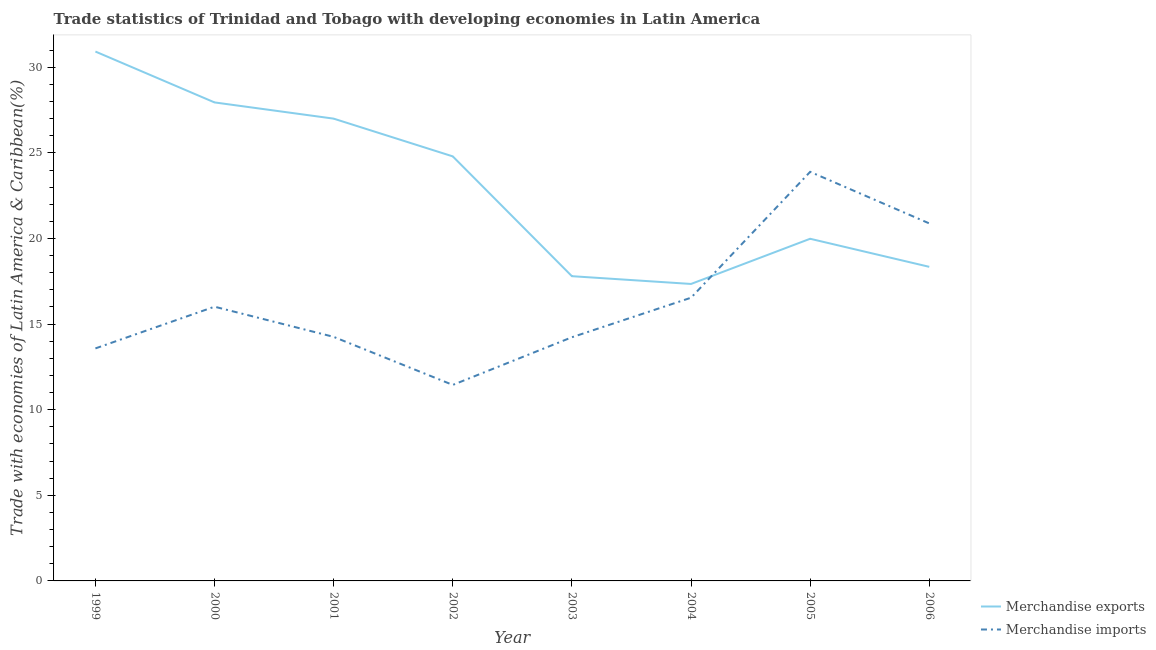Does the line corresponding to merchandise imports intersect with the line corresponding to merchandise exports?
Your answer should be compact. Yes. Is the number of lines equal to the number of legend labels?
Make the answer very short. Yes. What is the merchandise imports in 2005?
Make the answer very short. 23.89. Across all years, what is the maximum merchandise imports?
Offer a terse response. 23.89. Across all years, what is the minimum merchandise imports?
Provide a short and direct response. 11.45. What is the total merchandise exports in the graph?
Your answer should be very brief. 184.13. What is the difference between the merchandise imports in 1999 and that in 2005?
Your answer should be very brief. -10.31. What is the difference between the merchandise imports in 2003 and the merchandise exports in 2005?
Make the answer very short. -5.75. What is the average merchandise imports per year?
Keep it short and to the point. 16.36. In the year 2004, what is the difference between the merchandise imports and merchandise exports?
Your answer should be very brief. -0.8. In how many years, is the merchandise imports greater than 9 %?
Your answer should be very brief. 8. What is the ratio of the merchandise imports in 2001 to that in 2005?
Ensure brevity in your answer.  0.6. What is the difference between the highest and the second highest merchandise exports?
Give a very brief answer. 2.97. What is the difference between the highest and the lowest merchandise exports?
Provide a short and direct response. 13.57. Does the merchandise exports monotonically increase over the years?
Your answer should be compact. No. Is the merchandise exports strictly greater than the merchandise imports over the years?
Keep it short and to the point. No. Is the merchandise exports strictly less than the merchandise imports over the years?
Offer a very short reply. No. How many years are there in the graph?
Provide a succinct answer. 8. Does the graph contain grids?
Make the answer very short. No. What is the title of the graph?
Keep it short and to the point. Trade statistics of Trinidad and Tobago with developing economies in Latin America. What is the label or title of the Y-axis?
Provide a short and direct response. Trade with economies of Latin America & Caribbean(%). What is the Trade with economies of Latin America & Caribbean(%) in Merchandise exports in 1999?
Offer a terse response. 30.92. What is the Trade with economies of Latin America & Caribbean(%) of Merchandise imports in 1999?
Your answer should be compact. 13.58. What is the Trade with economies of Latin America & Caribbean(%) in Merchandise exports in 2000?
Ensure brevity in your answer.  27.95. What is the Trade with economies of Latin America & Caribbean(%) in Merchandise imports in 2000?
Ensure brevity in your answer.  16.02. What is the Trade with economies of Latin America & Caribbean(%) of Merchandise exports in 2001?
Keep it short and to the point. 27. What is the Trade with economies of Latin America & Caribbean(%) of Merchandise imports in 2001?
Your response must be concise. 14.25. What is the Trade with economies of Latin America & Caribbean(%) in Merchandise exports in 2002?
Make the answer very short. 24.8. What is the Trade with economies of Latin America & Caribbean(%) of Merchandise imports in 2002?
Your response must be concise. 11.45. What is the Trade with economies of Latin America & Caribbean(%) in Merchandise exports in 2003?
Keep it short and to the point. 17.8. What is the Trade with economies of Latin America & Caribbean(%) in Merchandise imports in 2003?
Make the answer very short. 14.23. What is the Trade with economies of Latin America & Caribbean(%) in Merchandise exports in 2004?
Your answer should be very brief. 17.34. What is the Trade with economies of Latin America & Caribbean(%) in Merchandise imports in 2004?
Offer a terse response. 16.54. What is the Trade with economies of Latin America & Caribbean(%) of Merchandise exports in 2005?
Provide a short and direct response. 19.98. What is the Trade with economies of Latin America & Caribbean(%) of Merchandise imports in 2005?
Make the answer very short. 23.89. What is the Trade with economies of Latin America & Caribbean(%) in Merchandise exports in 2006?
Provide a succinct answer. 18.34. What is the Trade with economies of Latin America & Caribbean(%) of Merchandise imports in 2006?
Your answer should be compact. 20.88. Across all years, what is the maximum Trade with economies of Latin America & Caribbean(%) in Merchandise exports?
Keep it short and to the point. 30.92. Across all years, what is the maximum Trade with economies of Latin America & Caribbean(%) of Merchandise imports?
Your answer should be compact. 23.89. Across all years, what is the minimum Trade with economies of Latin America & Caribbean(%) in Merchandise exports?
Offer a very short reply. 17.34. Across all years, what is the minimum Trade with economies of Latin America & Caribbean(%) of Merchandise imports?
Offer a terse response. 11.45. What is the total Trade with economies of Latin America & Caribbean(%) in Merchandise exports in the graph?
Your response must be concise. 184.13. What is the total Trade with economies of Latin America & Caribbean(%) of Merchandise imports in the graph?
Provide a succinct answer. 130.85. What is the difference between the Trade with economies of Latin America & Caribbean(%) in Merchandise exports in 1999 and that in 2000?
Provide a short and direct response. 2.97. What is the difference between the Trade with economies of Latin America & Caribbean(%) of Merchandise imports in 1999 and that in 2000?
Your answer should be compact. -2.44. What is the difference between the Trade with economies of Latin America & Caribbean(%) in Merchandise exports in 1999 and that in 2001?
Give a very brief answer. 3.92. What is the difference between the Trade with economies of Latin America & Caribbean(%) in Merchandise imports in 1999 and that in 2001?
Ensure brevity in your answer.  -0.67. What is the difference between the Trade with economies of Latin America & Caribbean(%) in Merchandise exports in 1999 and that in 2002?
Your response must be concise. 6.12. What is the difference between the Trade with economies of Latin America & Caribbean(%) in Merchandise imports in 1999 and that in 2002?
Provide a succinct answer. 2.13. What is the difference between the Trade with economies of Latin America & Caribbean(%) of Merchandise exports in 1999 and that in 2003?
Provide a short and direct response. 13.12. What is the difference between the Trade with economies of Latin America & Caribbean(%) of Merchandise imports in 1999 and that in 2003?
Ensure brevity in your answer.  -0.65. What is the difference between the Trade with economies of Latin America & Caribbean(%) in Merchandise exports in 1999 and that in 2004?
Make the answer very short. 13.57. What is the difference between the Trade with economies of Latin America & Caribbean(%) in Merchandise imports in 1999 and that in 2004?
Make the answer very short. -2.96. What is the difference between the Trade with economies of Latin America & Caribbean(%) of Merchandise exports in 1999 and that in 2005?
Ensure brevity in your answer.  10.94. What is the difference between the Trade with economies of Latin America & Caribbean(%) in Merchandise imports in 1999 and that in 2005?
Your answer should be very brief. -10.31. What is the difference between the Trade with economies of Latin America & Caribbean(%) in Merchandise exports in 1999 and that in 2006?
Provide a succinct answer. 12.57. What is the difference between the Trade with economies of Latin America & Caribbean(%) in Merchandise imports in 1999 and that in 2006?
Your answer should be compact. -7.3. What is the difference between the Trade with economies of Latin America & Caribbean(%) in Merchandise exports in 2000 and that in 2001?
Your answer should be compact. 0.95. What is the difference between the Trade with economies of Latin America & Caribbean(%) of Merchandise imports in 2000 and that in 2001?
Ensure brevity in your answer.  1.76. What is the difference between the Trade with economies of Latin America & Caribbean(%) of Merchandise exports in 2000 and that in 2002?
Offer a very short reply. 3.15. What is the difference between the Trade with economies of Latin America & Caribbean(%) in Merchandise imports in 2000 and that in 2002?
Your response must be concise. 4.57. What is the difference between the Trade with economies of Latin America & Caribbean(%) in Merchandise exports in 2000 and that in 2003?
Ensure brevity in your answer.  10.15. What is the difference between the Trade with economies of Latin America & Caribbean(%) in Merchandise imports in 2000 and that in 2003?
Offer a terse response. 1.78. What is the difference between the Trade with economies of Latin America & Caribbean(%) in Merchandise exports in 2000 and that in 2004?
Your answer should be compact. 10.6. What is the difference between the Trade with economies of Latin America & Caribbean(%) in Merchandise imports in 2000 and that in 2004?
Your answer should be very brief. -0.52. What is the difference between the Trade with economies of Latin America & Caribbean(%) in Merchandise exports in 2000 and that in 2005?
Offer a terse response. 7.96. What is the difference between the Trade with economies of Latin America & Caribbean(%) in Merchandise imports in 2000 and that in 2005?
Your answer should be compact. -7.88. What is the difference between the Trade with economies of Latin America & Caribbean(%) of Merchandise exports in 2000 and that in 2006?
Make the answer very short. 9.6. What is the difference between the Trade with economies of Latin America & Caribbean(%) of Merchandise imports in 2000 and that in 2006?
Offer a terse response. -4.86. What is the difference between the Trade with economies of Latin America & Caribbean(%) of Merchandise exports in 2001 and that in 2002?
Offer a very short reply. 2.2. What is the difference between the Trade with economies of Latin America & Caribbean(%) in Merchandise imports in 2001 and that in 2002?
Offer a very short reply. 2.81. What is the difference between the Trade with economies of Latin America & Caribbean(%) in Merchandise exports in 2001 and that in 2003?
Offer a very short reply. 9.2. What is the difference between the Trade with economies of Latin America & Caribbean(%) of Merchandise imports in 2001 and that in 2003?
Your answer should be compact. 0.02. What is the difference between the Trade with economies of Latin America & Caribbean(%) of Merchandise exports in 2001 and that in 2004?
Keep it short and to the point. 9.66. What is the difference between the Trade with economies of Latin America & Caribbean(%) in Merchandise imports in 2001 and that in 2004?
Your answer should be very brief. -2.29. What is the difference between the Trade with economies of Latin America & Caribbean(%) in Merchandise exports in 2001 and that in 2005?
Provide a succinct answer. 7.02. What is the difference between the Trade with economies of Latin America & Caribbean(%) in Merchandise imports in 2001 and that in 2005?
Your answer should be very brief. -9.64. What is the difference between the Trade with economies of Latin America & Caribbean(%) of Merchandise exports in 2001 and that in 2006?
Offer a very short reply. 8.66. What is the difference between the Trade with economies of Latin America & Caribbean(%) of Merchandise imports in 2001 and that in 2006?
Offer a very short reply. -6.63. What is the difference between the Trade with economies of Latin America & Caribbean(%) of Merchandise exports in 2002 and that in 2003?
Make the answer very short. 7. What is the difference between the Trade with economies of Latin America & Caribbean(%) in Merchandise imports in 2002 and that in 2003?
Provide a succinct answer. -2.78. What is the difference between the Trade with economies of Latin America & Caribbean(%) of Merchandise exports in 2002 and that in 2004?
Your response must be concise. 7.45. What is the difference between the Trade with economies of Latin America & Caribbean(%) in Merchandise imports in 2002 and that in 2004?
Give a very brief answer. -5.09. What is the difference between the Trade with economies of Latin America & Caribbean(%) in Merchandise exports in 2002 and that in 2005?
Your response must be concise. 4.81. What is the difference between the Trade with economies of Latin America & Caribbean(%) of Merchandise imports in 2002 and that in 2005?
Your answer should be very brief. -12.45. What is the difference between the Trade with economies of Latin America & Caribbean(%) of Merchandise exports in 2002 and that in 2006?
Keep it short and to the point. 6.45. What is the difference between the Trade with economies of Latin America & Caribbean(%) in Merchandise imports in 2002 and that in 2006?
Offer a terse response. -9.43. What is the difference between the Trade with economies of Latin America & Caribbean(%) of Merchandise exports in 2003 and that in 2004?
Provide a succinct answer. 0.45. What is the difference between the Trade with economies of Latin America & Caribbean(%) in Merchandise imports in 2003 and that in 2004?
Offer a very short reply. -2.31. What is the difference between the Trade with economies of Latin America & Caribbean(%) of Merchandise exports in 2003 and that in 2005?
Your answer should be compact. -2.19. What is the difference between the Trade with economies of Latin America & Caribbean(%) in Merchandise imports in 2003 and that in 2005?
Offer a terse response. -9.66. What is the difference between the Trade with economies of Latin America & Caribbean(%) of Merchandise exports in 2003 and that in 2006?
Give a very brief answer. -0.55. What is the difference between the Trade with economies of Latin America & Caribbean(%) of Merchandise imports in 2003 and that in 2006?
Provide a succinct answer. -6.65. What is the difference between the Trade with economies of Latin America & Caribbean(%) in Merchandise exports in 2004 and that in 2005?
Provide a short and direct response. -2.64. What is the difference between the Trade with economies of Latin America & Caribbean(%) of Merchandise imports in 2004 and that in 2005?
Provide a short and direct response. -7.35. What is the difference between the Trade with economies of Latin America & Caribbean(%) of Merchandise exports in 2004 and that in 2006?
Provide a short and direct response. -1. What is the difference between the Trade with economies of Latin America & Caribbean(%) of Merchandise imports in 2004 and that in 2006?
Your answer should be very brief. -4.34. What is the difference between the Trade with economies of Latin America & Caribbean(%) in Merchandise exports in 2005 and that in 2006?
Offer a terse response. 1.64. What is the difference between the Trade with economies of Latin America & Caribbean(%) in Merchandise imports in 2005 and that in 2006?
Provide a short and direct response. 3.01. What is the difference between the Trade with economies of Latin America & Caribbean(%) in Merchandise exports in 1999 and the Trade with economies of Latin America & Caribbean(%) in Merchandise imports in 2000?
Your answer should be very brief. 14.9. What is the difference between the Trade with economies of Latin America & Caribbean(%) in Merchandise exports in 1999 and the Trade with economies of Latin America & Caribbean(%) in Merchandise imports in 2001?
Keep it short and to the point. 16.66. What is the difference between the Trade with economies of Latin America & Caribbean(%) of Merchandise exports in 1999 and the Trade with economies of Latin America & Caribbean(%) of Merchandise imports in 2002?
Your answer should be compact. 19.47. What is the difference between the Trade with economies of Latin America & Caribbean(%) in Merchandise exports in 1999 and the Trade with economies of Latin America & Caribbean(%) in Merchandise imports in 2003?
Your answer should be compact. 16.69. What is the difference between the Trade with economies of Latin America & Caribbean(%) in Merchandise exports in 1999 and the Trade with economies of Latin America & Caribbean(%) in Merchandise imports in 2004?
Make the answer very short. 14.38. What is the difference between the Trade with economies of Latin America & Caribbean(%) of Merchandise exports in 1999 and the Trade with economies of Latin America & Caribbean(%) of Merchandise imports in 2005?
Offer a very short reply. 7.03. What is the difference between the Trade with economies of Latin America & Caribbean(%) in Merchandise exports in 1999 and the Trade with economies of Latin America & Caribbean(%) in Merchandise imports in 2006?
Your response must be concise. 10.04. What is the difference between the Trade with economies of Latin America & Caribbean(%) of Merchandise exports in 2000 and the Trade with economies of Latin America & Caribbean(%) of Merchandise imports in 2001?
Your answer should be compact. 13.69. What is the difference between the Trade with economies of Latin America & Caribbean(%) in Merchandise exports in 2000 and the Trade with economies of Latin America & Caribbean(%) in Merchandise imports in 2002?
Offer a very short reply. 16.5. What is the difference between the Trade with economies of Latin America & Caribbean(%) of Merchandise exports in 2000 and the Trade with economies of Latin America & Caribbean(%) of Merchandise imports in 2003?
Provide a short and direct response. 13.72. What is the difference between the Trade with economies of Latin America & Caribbean(%) of Merchandise exports in 2000 and the Trade with economies of Latin America & Caribbean(%) of Merchandise imports in 2004?
Provide a short and direct response. 11.41. What is the difference between the Trade with economies of Latin America & Caribbean(%) in Merchandise exports in 2000 and the Trade with economies of Latin America & Caribbean(%) in Merchandise imports in 2005?
Offer a very short reply. 4.05. What is the difference between the Trade with economies of Latin America & Caribbean(%) in Merchandise exports in 2000 and the Trade with economies of Latin America & Caribbean(%) in Merchandise imports in 2006?
Provide a succinct answer. 7.07. What is the difference between the Trade with economies of Latin America & Caribbean(%) of Merchandise exports in 2001 and the Trade with economies of Latin America & Caribbean(%) of Merchandise imports in 2002?
Give a very brief answer. 15.55. What is the difference between the Trade with economies of Latin America & Caribbean(%) of Merchandise exports in 2001 and the Trade with economies of Latin America & Caribbean(%) of Merchandise imports in 2003?
Your answer should be compact. 12.77. What is the difference between the Trade with economies of Latin America & Caribbean(%) of Merchandise exports in 2001 and the Trade with economies of Latin America & Caribbean(%) of Merchandise imports in 2004?
Provide a succinct answer. 10.46. What is the difference between the Trade with economies of Latin America & Caribbean(%) in Merchandise exports in 2001 and the Trade with economies of Latin America & Caribbean(%) in Merchandise imports in 2005?
Offer a terse response. 3.11. What is the difference between the Trade with economies of Latin America & Caribbean(%) in Merchandise exports in 2001 and the Trade with economies of Latin America & Caribbean(%) in Merchandise imports in 2006?
Provide a short and direct response. 6.12. What is the difference between the Trade with economies of Latin America & Caribbean(%) in Merchandise exports in 2002 and the Trade with economies of Latin America & Caribbean(%) in Merchandise imports in 2003?
Your response must be concise. 10.56. What is the difference between the Trade with economies of Latin America & Caribbean(%) in Merchandise exports in 2002 and the Trade with economies of Latin America & Caribbean(%) in Merchandise imports in 2004?
Your answer should be compact. 8.25. What is the difference between the Trade with economies of Latin America & Caribbean(%) in Merchandise exports in 2002 and the Trade with economies of Latin America & Caribbean(%) in Merchandise imports in 2005?
Keep it short and to the point. 0.9. What is the difference between the Trade with economies of Latin America & Caribbean(%) in Merchandise exports in 2002 and the Trade with economies of Latin America & Caribbean(%) in Merchandise imports in 2006?
Provide a short and direct response. 3.91. What is the difference between the Trade with economies of Latin America & Caribbean(%) in Merchandise exports in 2003 and the Trade with economies of Latin America & Caribbean(%) in Merchandise imports in 2004?
Offer a very short reply. 1.26. What is the difference between the Trade with economies of Latin America & Caribbean(%) in Merchandise exports in 2003 and the Trade with economies of Latin America & Caribbean(%) in Merchandise imports in 2005?
Keep it short and to the point. -6.09. What is the difference between the Trade with economies of Latin America & Caribbean(%) in Merchandise exports in 2003 and the Trade with economies of Latin America & Caribbean(%) in Merchandise imports in 2006?
Provide a short and direct response. -3.08. What is the difference between the Trade with economies of Latin America & Caribbean(%) of Merchandise exports in 2004 and the Trade with economies of Latin America & Caribbean(%) of Merchandise imports in 2005?
Provide a succinct answer. -6.55. What is the difference between the Trade with economies of Latin America & Caribbean(%) in Merchandise exports in 2004 and the Trade with economies of Latin America & Caribbean(%) in Merchandise imports in 2006?
Make the answer very short. -3.54. What is the difference between the Trade with economies of Latin America & Caribbean(%) of Merchandise exports in 2005 and the Trade with economies of Latin America & Caribbean(%) of Merchandise imports in 2006?
Your answer should be very brief. -0.9. What is the average Trade with economies of Latin America & Caribbean(%) of Merchandise exports per year?
Ensure brevity in your answer.  23.02. What is the average Trade with economies of Latin America & Caribbean(%) in Merchandise imports per year?
Offer a terse response. 16.36. In the year 1999, what is the difference between the Trade with economies of Latin America & Caribbean(%) in Merchandise exports and Trade with economies of Latin America & Caribbean(%) in Merchandise imports?
Offer a very short reply. 17.34. In the year 2000, what is the difference between the Trade with economies of Latin America & Caribbean(%) of Merchandise exports and Trade with economies of Latin America & Caribbean(%) of Merchandise imports?
Give a very brief answer. 11.93. In the year 2001, what is the difference between the Trade with economies of Latin America & Caribbean(%) of Merchandise exports and Trade with economies of Latin America & Caribbean(%) of Merchandise imports?
Ensure brevity in your answer.  12.75. In the year 2002, what is the difference between the Trade with economies of Latin America & Caribbean(%) of Merchandise exports and Trade with economies of Latin America & Caribbean(%) of Merchandise imports?
Offer a terse response. 13.35. In the year 2003, what is the difference between the Trade with economies of Latin America & Caribbean(%) in Merchandise exports and Trade with economies of Latin America & Caribbean(%) in Merchandise imports?
Provide a succinct answer. 3.57. In the year 2004, what is the difference between the Trade with economies of Latin America & Caribbean(%) in Merchandise exports and Trade with economies of Latin America & Caribbean(%) in Merchandise imports?
Give a very brief answer. 0.8. In the year 2005, what is the difference between the Trade with economies of Latin America & Caribbean(%) of Merchandise exports and Trade with economies of Latin America & Caribbean(%) of Merchandise imports?
Offer a terse response. -3.91. In the year 2006, what is the difference between the Trade with economies of Latin America & Caribbean(%) of Merchandise exports and Trade with economies of Latin America & Caribbean(%) of Merchandise imports?
Provide a succinct answer. -2.54. What is the ratio of the Trade with economies of Latin America & Caribbean(%) in Merchandise exports in 1999 to that in 2000?
Your response must be concise. 1.11. What is the ratio of the Trade with economies of Latin America & Caribbean(%) in Merchandise imports in 1999 to that in 2000?
Offer a terse response. 0.85. What is the ratio of the Trade with economies of Latin America & Caribbean(%) of Merchandise exports in 1999 to that in 2001?
Your answer should be very brief. 1.15. What is the ratio of the Trade with economies of Latin America & Caribbean(%) in Merchandise imports in 1999 to that in 2001?
Offer a very short reply. 0.95. What is the ratio of the Trade with economies of Latin America & Caribbean(%) of Merchandise exports in 1999 to that in 2002?
Your answer should be compact. 1.25. What is the ratio of the Trade with economies of Latin America & Caribbean(%) of Merchandise imports in 1999 to that in 2002?
Give a very brief answer. 1.19. What is the ratio of the Trade with economies of Latin America & Caribbean(%) of Merchandise exports in 1999 to that in 2003?
Offer a terse response. 1.74. What is the ratio of the Trade with economies of Latin America & Caribbean(%) of Merchandise imports in 1999 to that in 2003?
Make the answer very short. 0.95. What is the ratio of the Trade with economies of Latin America & Caribbean(%) of Merchandise exports in 1999 to that in 2004?
Make the answer very short. 1.78. What is the ratio of the Trade with economies of Latin America & Caribbean(%) in Merchandise imports in 1999 to that in 2004?
Your answer should be compact. 0.82. What is the ratio of the Trade with economies of Latin America & Caribbean(%) of Merchandise exports in 1999 to that in 2005?
Offer a very short reply. 1.55. What is the ratio of the Trade with economies of Latin America & Caribbean(%) in Merchandise imports in 1999 to that in 2005?
Offer a terse response. 0.57. What is the ratio of the Trade with economies of Latin America & Caribbean(%) of Merchandise exports in 1999 to that in 2006?
Keep it short and to the point. 1.69. What is the ratio of the Trade with economies of Latin America & Caribbean(%) in Merchandise imports in 1999 to that in 2006?
Your answer should be compact. 0.65. What is the ratio of the Trade with economies of Latin America & Caribbean(%) of Merchandise exports in 2000 to that in 2001?
Ensure brevity in your answer.  1.04. What is the ratio of the Trade with economies of Latin America & Caribbean(%) in Merchandise imports in 2000 to that in 2001?
Your answer should be very brief. 1.12. What is the ratio of the Trade with economies of Latin America & Caribbean(%) of Merchandise exports in 2000 to that in 2002?
Offer a terse response. 1.13. What is the ratio of the Trade with economies of Latin America & Caribbean(%) in Merchandise imports in 2000 to that in 2002?
Your response must be concise. 1.4. What is the ratio of the Trade with economies of Latin America & Caribbean(%) of Merchandise exports in 2000 to that in 2003?
Ensure brevity in your answer.  1.57. What is the ratio of the Trade with economies of Latin America & Caribbean(%) of Merchandise imports in 2000 to that in 2003?
Offer a very short reply. 1.13. What is the ratio of the Trade with economies of Latin America & Caribbean(%) of Merchandise exports in 2000 to that in 2004?
Provide a succinct answer. 1.61. What is the ratio of the Trade with economies of Latin America & Caribbean(%) in Merchandise imports in 2000 to that in 2004?
Keep it short and to the point. 0.97. What is the ratio of the Trade with economies of Latin America & Caribbean(%) in Merchandise exports in 2000 to that in 2005?
Ensure brevity in your answer.  1.4. What is the ratio of the Trade with economies of Latin America & Caribbean(%) of Merchandise imports in 2000 to that in 2005?
Make the answer very short. 0.67. What is the ratio of the Trade with economies of Latin America & Caribbean(%) of Merchandise exports in 2000 to that in 2006?
Provide a succinct answer. 1.52. What is the ratio of the Trade with economies of Latin America & Caribbean(%) in Merchandise imports in 2000 to that in 2006?
Your response must be concise. 0.77. What is the ratio of the Trade with economies of Latin America & Caribbean(%) in Merchandise exports in 2001 to that in 2002?
Make the answer very short. 1.09. What is the ratio of the Trade with economies of Latin America & Caribbean(%) in Merchandise imports in 2001 to that in 2002?
Give a very brief answer. 1.25. What is the ratio of the Trade with economies of Latin America & Caribbean(%) of Merchandise exports in 2001 to that in 2003?
Provide a short and direct response. 1.52. What is the ratio of the Trade with economies of Latin America & Caribbean(%) in Merchandise imports in 2001 to that in 2003?
Offer a very short reply. 1. What is the ratio of the Trade with economies of Latin America & Caribbean(%) of Merchandise exports in 2001 to that in 2004?
Provide a succinct answer. 1.56. What is the ratio of the Trade with economies of Latin America & Caribbean(%) in Merchandise imports in 2001 to that in 2004?
Give a very brief answer. 0.86. What is the ratio of the Trade with economies of Latin America & Caribbean(%) in Merchandise exports in 2001 to that in 2005?
Give a very brief answer. 1.35. What is the ratio of the Trade with economies of Latin America & Caribbean(%) of Merchandise imports in 2001 to that in 2005?
Your answer should be compact. 0.6. What is the ratio of the Trade with economies of Latin America & Caribbean(%) of Merchandise exports in 2001 to that in 2006?
Ensure brevity in your answer.  1.47. What is the ratio of the Trade with economies of Latin America & Caribbean(%) of Merchandise imports in 2001 to that in 2006?
Make the answer very short. 0.68. What is the ratio of the Trade with economies of Latin America & Caribbean(%) of Merchandise exports in 2002 to that in 2003?
Keep it short and to the point. 1.39. What is the ratio of the Trade with economies of Latin America & Caribbean(%) in Merchandise imports in 2002 to that in 2003?
Provide a succinct answer. 0.8. What is the ratio of the Trade with economies of Latin America & Caribbean(%) in Merchandise exports in 2002 to that in 2004?
Ensure brevity in your answer.  1.43. What is the ratio of the Trade with economies of Latin America & Caribbean(%) of Merchandise imports in 2002 to that in 2004?
Make the answer very short. 0.69. What is the ratio of the Trade with economies of Latin America & Caribbean(%) of Merchandise exports in 2002 to that in 2005?
Offer a very short reply. 1.24. What is the ratio of the Trade with economies of Latin America & Caribbean(%) of Merchandise imports in 2002 to that in 2005?
Offer a very short reply. 0.48. What is the ratio of the Trade with economies of Latin America & Caribbean(%) of Merchandise exports in 2002 to that in 2006?
Your answer should be very brief. 1.35. What is the ratio of the Trade with economies of Latin America & Caribbean(%) in Merchandise imports in 2002 to that in 2006?
Your answer should be compact. 0.55. What is the ratio of the Trade with economies of Latin America & Caribbean(%) of Merchandise exports in 2003 to that in 2004?
Provide a short and direct response. 1.03. What is the ratio of the Trade with economies of Latin America & Caribbean(%) of Merchandise imports in 2003 to that in 2004?
Offer a very short reply. 0.86. What is the ratio of the Trade with economies of Latin America & Caribbean(%) in Merchandise exports in 2003 to that in 2005?
Your response must be concise. 0.89. What is the ratio of the Trade with economies of Latin America & Caribbean(%) in Merchandise imports in 2003 to that in 2005?
Offer a very short reply. 0.6. What is the ratio of the Trade with economies of Latin America & Caribbean(%) in Merchandise exports in 2003 to that in 2006?
Provide a short and direct response. 0.97. What is the ratio of the Trade with economies of Latin America & Caribbean(%) in Merchandise imports in 2003 to that in 2006?
Make the answer very short. 0.68. What is the ratio of the Trade with economies of Latin America & Caribbean(%) in Merchandise exports in 2004 to that in 2005?
Offer a very short reply. 0.87. What is the ratio of the Trade with economies of Latin America & Caribbean(%) of Merchandise imports in 2004 to that in 2005?
Keep it short and to the point. 0.69. What is the ratio of the Trade with economies of Latin America & Caribbean(%) of Merchandise exports in 2004 to that in 2006?
Give a very brief answer. 0.95. What is the ratio of the Trade with economies of Latin America & Caribbean(%) in Merchandise imports in 2004 to that in 2006?
Your answer should be very brief. 0.79. What is the ratio of the Trade with economies of Latin America & Caribbean(%) in Merchandise exports in 2005 to that in 2006?
Give a very brief answer. 1.09. What is the ratio of the Trade with economies of Latin America & Caribbean(%) in Merchandise imports in 2005 to that in 2006?
Give a very brief answer. 1.14. What is the difference between the highest and the second highest Trade with economies of Latin America & Caribbean(%) in Merchandise exports?
Keep it short and to the point. 2.97. What is the difference between the highest and the second highest Trade with economies of Latin America & Caribbean(%) in Merchandise imports?
Your answer should be compact. 3.01. What is the difference between the highest and the lowest Trade with economies of Latin America & Caribbean(%) of Merchandise exports?
Your answer should be compact. 13.57. What is the difference between the highest and the lowest Trade with economies of Latin America & Caribbean(%) in Merchandise imports?
Offer a very short reply. 12.45. 